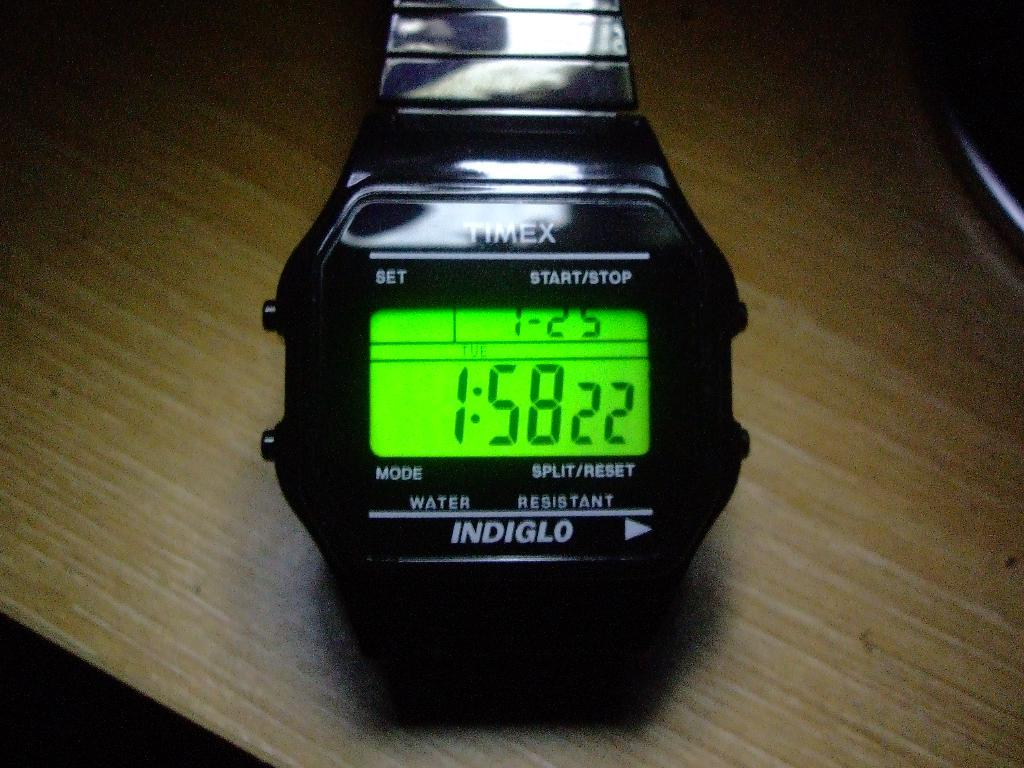<image>
Share a concise interpretation of the image provided. The black Timex watch is illuminated by Indiglo. 